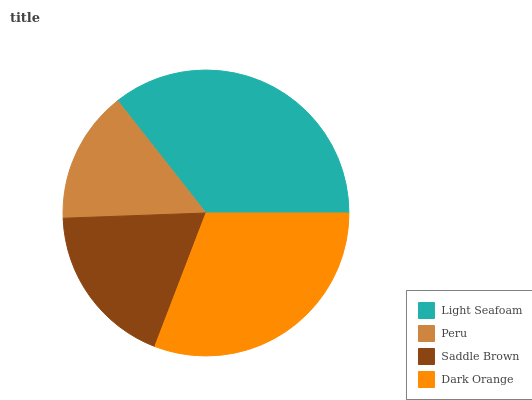Is Peru the minimum?
Answer yes or no. Yes. Is Light Seafoam the maximum?
Answer yes or no. Yes. Is Saddle Brown the minimum?
Answer yes or no. No. Is Saddle Brown the maximum?
Answer yes or no. No. Is Saddle Brown greater than Peru?
Answer yes or no. Yes. Is Peru less than Saddle Brown?
Answer yes or no. Yes. Is Peru greater than Saddle Brown?
Answer yes or no. No. Is Saddle Brown less than Peru?
Answer yes or no. No. Is Dark Orange the high median?
Answer yes or no. Yes. Is Saddle Brown the low median?
Answer yes or no. Yes. Is Light Seafoam the high median?
Answer yes or no. No. Is Dark Orange the low median?
Answer yes or no. No. 